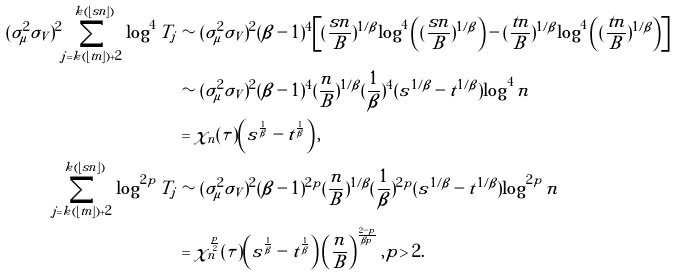Convert formula to latex. <formula><loc_0><loc_0><loc_500><loc_500>( \sigma _ { \mu } ^ { 2 } \sigma _ { V } ) ^ { 2 } \sum _ { j = k ( \lfloor t n \rfloor ) + 2 } ^ { k ( \lfloor s n \rfloor ) } \log ^ { 4 } T _ { j } & \sim ( \sigma _ { \mu } ^ { 2 } \sigma _ { V } ) ^ { 2 } ( \beta - 1 ) ^ { 4 } \left [ ( \frac { s n } { B } ) ^ { 1 / \beta } \log ^ { 4 } \left ( ( \frac { s n } { B } ) ^ { 1 / \beta } \right ) - ( \frac { t n } { B } ) ^ { 1 / \beta } \log ^ { 4 } \left ( ( \frac { t n } { B } ) ^ { 1 / \beta } \right ) \right ] \\ & \sim ( \sigma _ { \mu } ^ { 2 } \sigma _ { V } ) ^ { 2 } ( \beta - 1 ) ^ { 4 } ( \frac { n } { B } ) ^ { 1 / \beta } ( \frac { 1 } { \beta } ) ^ { 4 } ( s ^ { 1 / \beta } - t ^ { 1 / \beta } ) \log ^ { 4 } n \\ & = \chi _ { n } ( \tau ) \left ( s ^ { \frac { 1 } { \beta } } - t ^ { \frac { 1 } { \beta } } \right ) , \\ \sum _ { j = k ( \lfloor t n \rfloor ) + 2 } ^ { k ( \lfloor s n \rfloor ) } \log ^ { 2 p } T _ { j } & \sim ( \sigma _ { \mu } ^ { 2 } \sigma _ { V } ) ^ { 2 } ( \beta - 1 ) ^ { 2 p } ( \frac { n } { B } ) ^ { 1 / \beta } ( \frac { 1 } { \beta } ) ^ { 2 p } ( s ^ { 1 / \beta } - t ^ { 1 / \beta } ) \log ^ { 2 p } n \\ & = \chi _ { n } ^ { \frac { p } { 2 } } ( \tau ) \left ( s ^ { \frac { 1 } { \beta } } - t ^ { \frac { 1 } { \beta } } \right ) \left ( \frac { n } { B } \right ) ^ { \frac { 2 - p } { \beta p } } , p > 2 .</formula> 